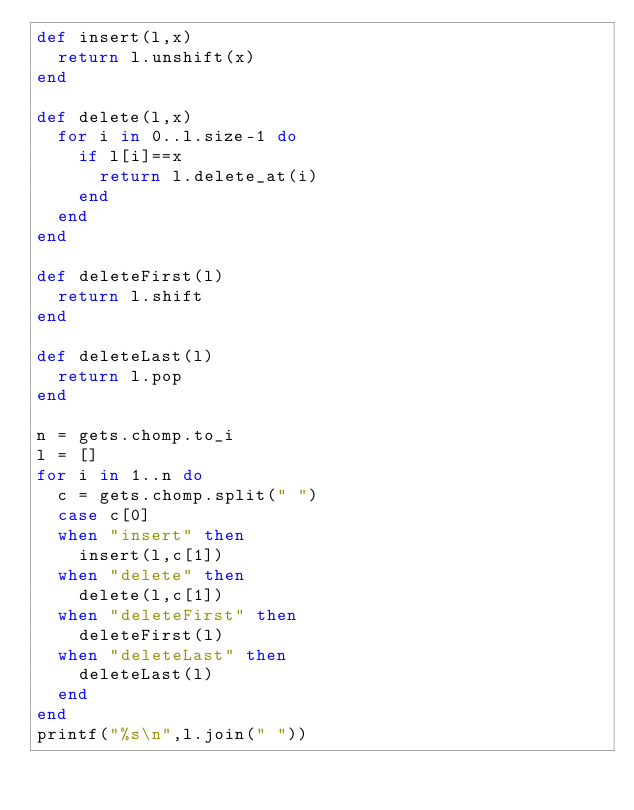<code> <loc_0><loc_0><loc_500><loc_500><_Ruby_>def insert(l,x)
  return l.unshift(x)
end

def delete(l,x)
  for i in 0..l.size-1 do
    if l[i]==x
      return l.delete_at(i)
    end
  end
end

def deleteFirst(l)
  return l.shift
end

def deleteLast(l)
  return l.pop
end

n = gets.chomp.to_i
l = []
for i in 1..n do
  c = gets.chomp.split(" ")
  case c[0]
  when "insert" then
    insert(l,c[1])
  when "delete" then
    delete(l,c[1])
  when "deleteFirst" then
    deleteFirst(l)
  when "deleteLast" then
    deleteLast(l)
  end
end
printf("%s\n",l.join(" "))
</code> 